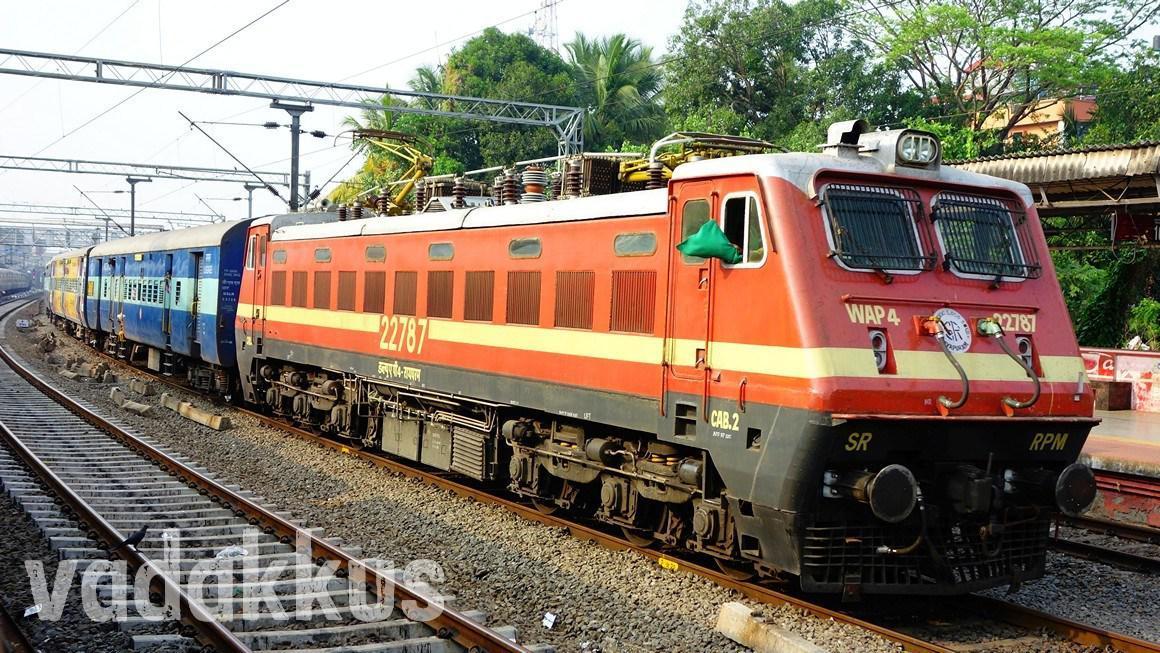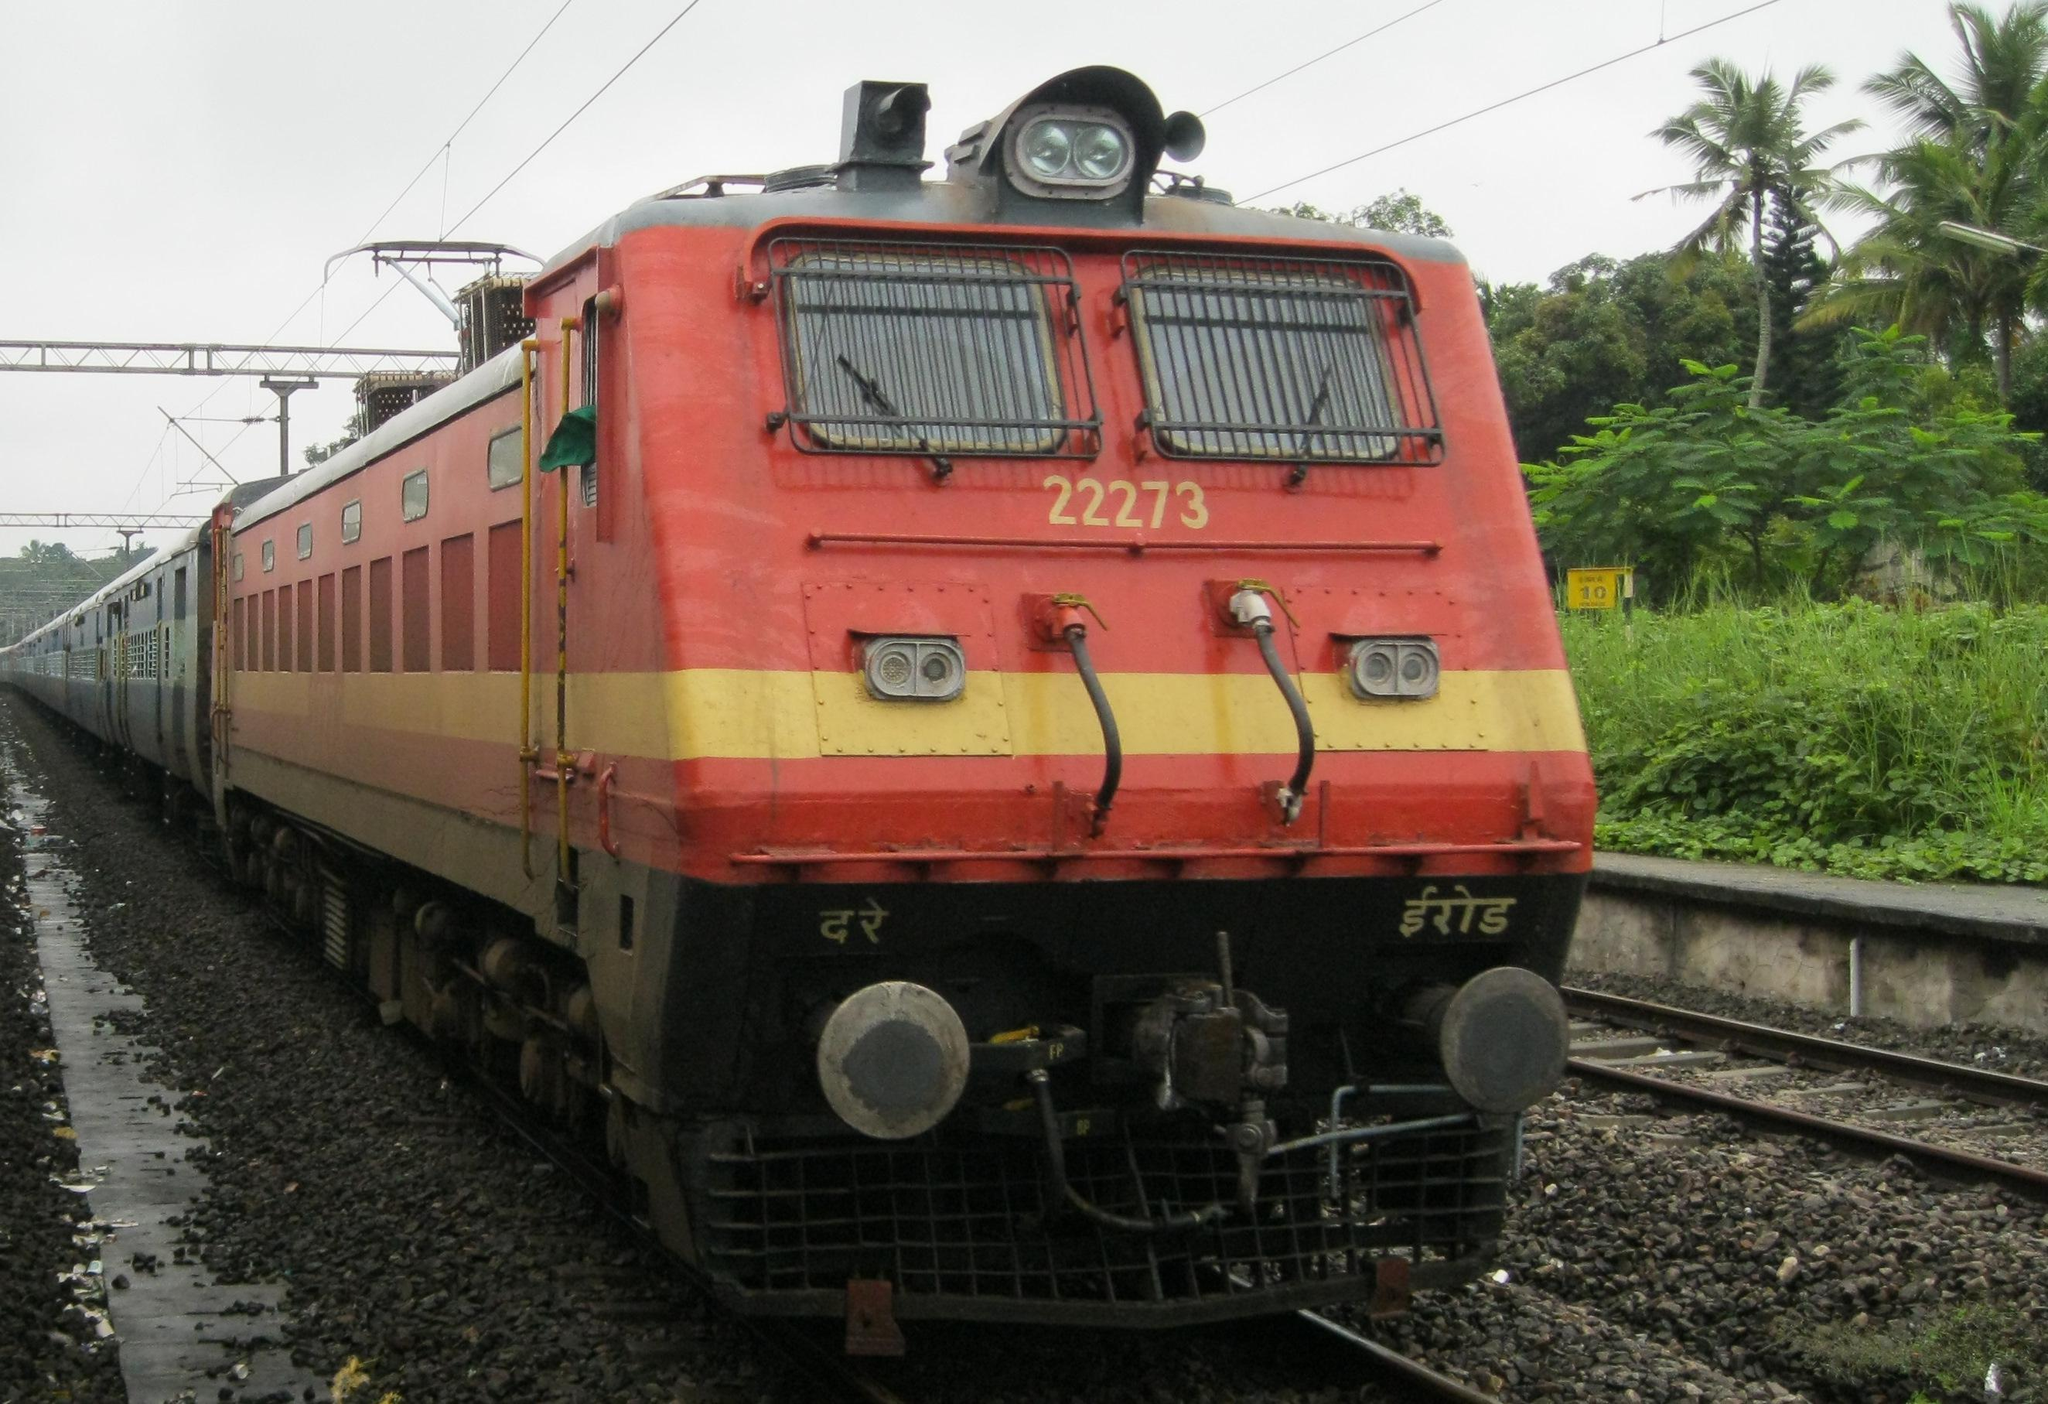The first image is the image on the left, the second image is the image on the right. Assess this claim about the two images: "The train in the image on the right has grates covering its front windows.". Correct or not? Answer yes or no. Yes. 